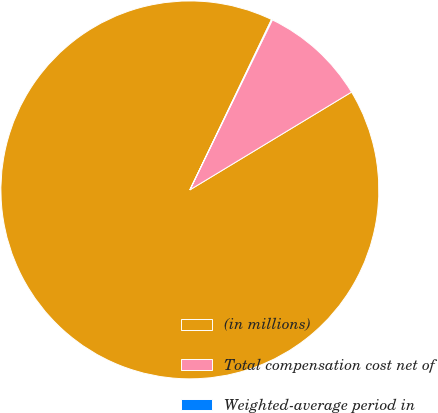<chart> <loc_0><loc_0><loc_500><loc_500><pie_chart><fcel>(in millions)<fcel>Total compensation cost net of<fcel>Weighted-average period in<nl><fcel>90.77%<fcel>9.15%<fcel>0.08%<nl></chart> 